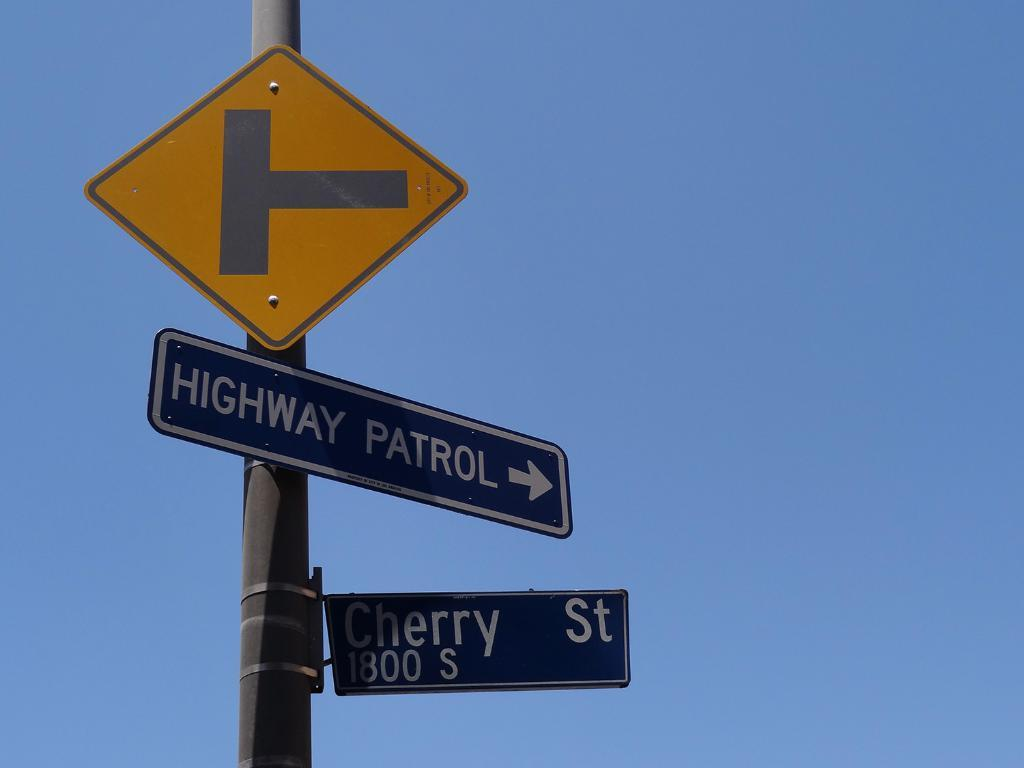<image>
Offer a succinct explanation of the picture presented. a sign that says highway patrol on it 